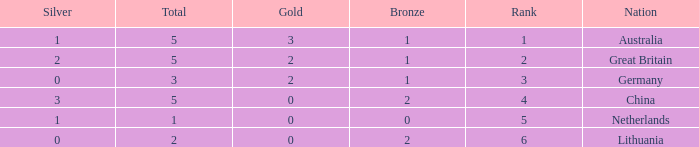How many total show when silver is 0, bronze is 1, and the rank is less than 3? 0.0. 